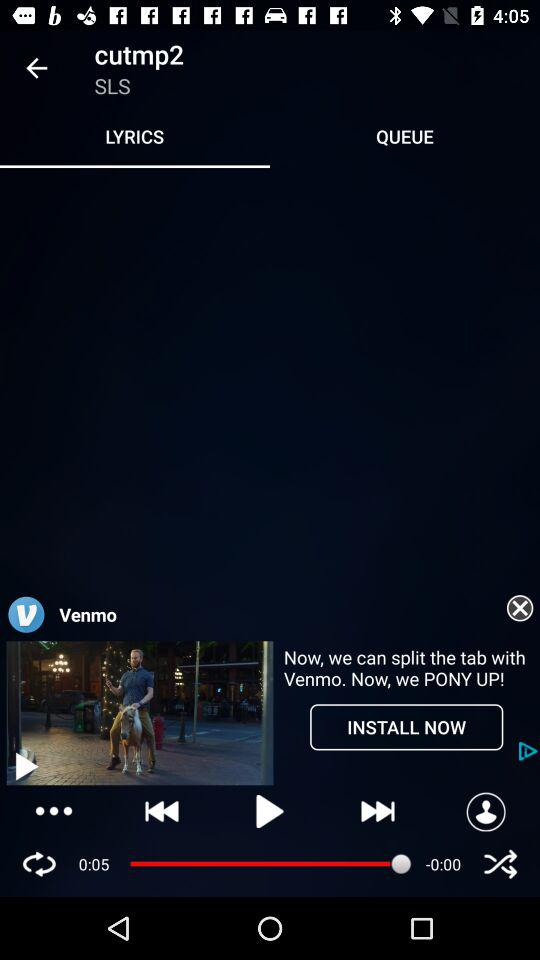Which tab am I on? You are on the "LYRICS" tab. 